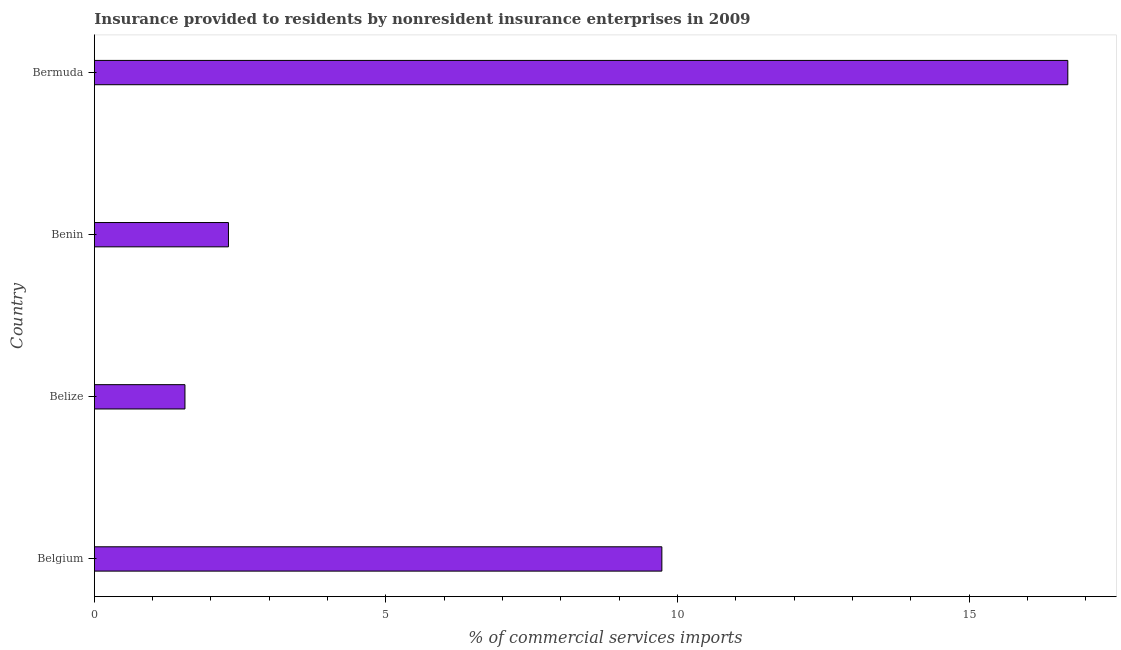Does the graph contain any zero values?
Provide a succinct answer. No. Does the graph contain grids?
Your answer should be compact. No. What is the title of the graph?
Offer a terse response. Insurance provided to residents by nonresident insurance enterprises in 2009. What is the label or title of the X-axis?
Your answer should be very brief. % of commercial services imports. What is the insurance provided by non-residents in Benin?
Offer a very short reply. 2.3. Across all countries, what is the maximum insurance provided by non-residents?
Your answer should be compact. 16.69. Across all countries, what is the minimum insurance provided by non-residents?
Offer a very short reply. 1.55. In which country was the insurance provided by non-residents maximum?
Your answer should be compact. Bermuda. In which country was the insurance provided by non-residents minimum?
Your answer should be compact. Belize. What is the sum of the insurance provided by non-residents?
Provide a short and direct response. 30.28. What is the difference between the insurance provided by non-residents in Belgium and Bermuda?
Offer a very short reply. -6.96. What is the average insurance provided by non-residents per country?
Offer a very short reply. 7.57. What is the median insurance provided by non-residents?
Make the answer very short. 6.02. In how many countries, is the insurance provided by non-residents greater than 6 %?
Ensure brevity in your answer.  2. What is the ratio of the insurance provided by non-residents in Belgium to that in Belize?
Make the answer very short. 6.26. Is the difference between the insurance provided by non-residents in Belgium and Benin greater than the difference between any two countries?
Make the answer very short. No. What is the difference between the highest and the second highest insurance provided by non-residents?
Provide a short and direct response. 6.96. Is the sum of the insurance provided by non-residents in Belgium and Benin greater than the maximum insurance provided by non-residents across all countries?
Provide a succinct answer. No. What is the difference between the highest and the lowest insurance provided by non-residents?
Give a very brief answer. 15.14. In how many countries, is the insurance provided by non-residents greater than the average insurance provided by non-residents taken over all countries?
Your answer should be very brief. 2. Are all the bars in the graph horizontal?
Your answer should be compact. Yes. How many countries are there in the graph?
Offer a terse response. 4. What is the difference between two consecutive major ticks on the X-axis?
Your response must be concise. 5. What is the % of commercial services imports in Belgium?
Keep it short and to the point. 9.73. What is the % of commercial services imports in Belize?
Keep it short and to the point. 1.55. What is the % of commercial services imports in Benin?
Make the answer very short. 2.3. What is the % of commercial services imports in Bermuda?
Give a very brief answer. 16.69. What is the difference between the % of commercial services imports in Belgium and Belize?
Give a very brief answer. 8.18. What is the difference between the % of commercial services imports in Belgium and Benin?
Your response must be concise. 7.43. What is the difference between the % of commercial services imports in Belgium and Bermuda?
Your response must be concise. -6.96. What is the difference between the % of commercial services imports in Belize and Benin?
Keep it short and to the point. -0.75. What is the difference between the % of commercial services imports in Belize and Bermuda?
Your answer should be compact. -15.14. What is the difference between the % of commercial services imports in Benin and Bermuda?
Offer a terse response. -14.39. What is the ratio of the % of commercial services imports in Belgium to that in Belize?
Offer a very short reply. 6.26. What is the ratio of the % of commercial services imports in Belgium to that in Benin?
Give a very brief answer. 4.23. What is the ratio of the % of commercial services imports in Belgium to that in Bermuda?
Offer a very short reply. 0.58. What is the ratio of the % of commercial services imports in Belize to that in Benin?
Offer a very short reply. 0.68. What is the ratio of the % of commercial services imports in Belize to that in Bermuda?
Your answer should be very brief. 0.09. What is the ratio of the % of commercial services imports in Benin to that in Bermuda?
Provide a succinct answer. 0.14. 